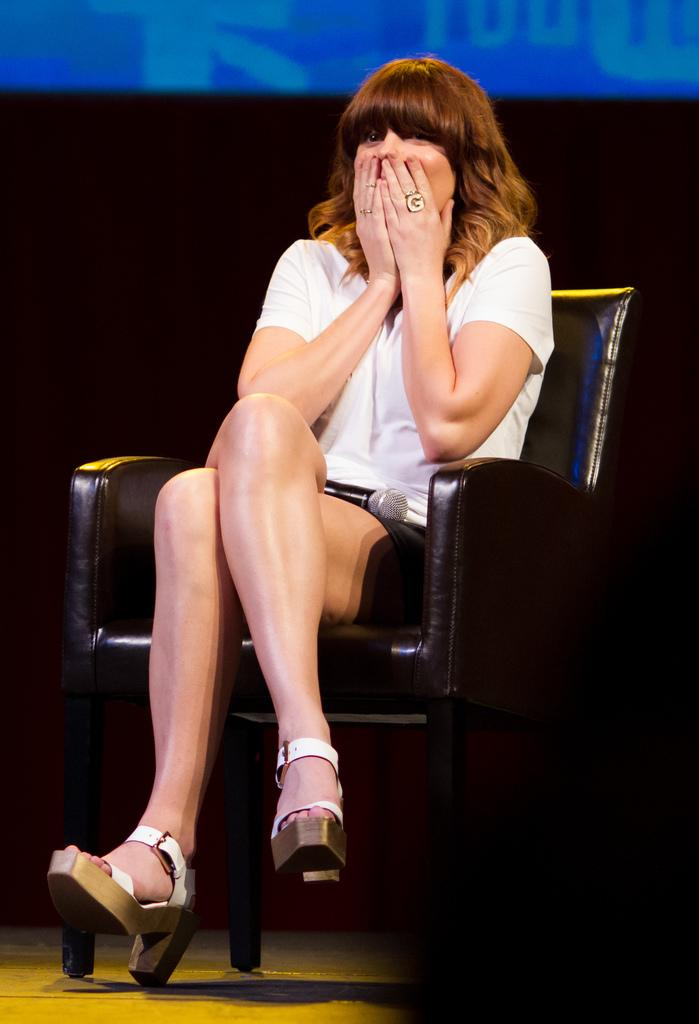Who is present in the image? There is a woman in the image. What is the woman wearing? The woman is wearing a white dress. What is the woman doing in the image? The woman is sitting on a chair. What can be seen in the background of the image? There is a screen in the background of the image. Where can the lead be found in the image? There is no lead present in the image. 